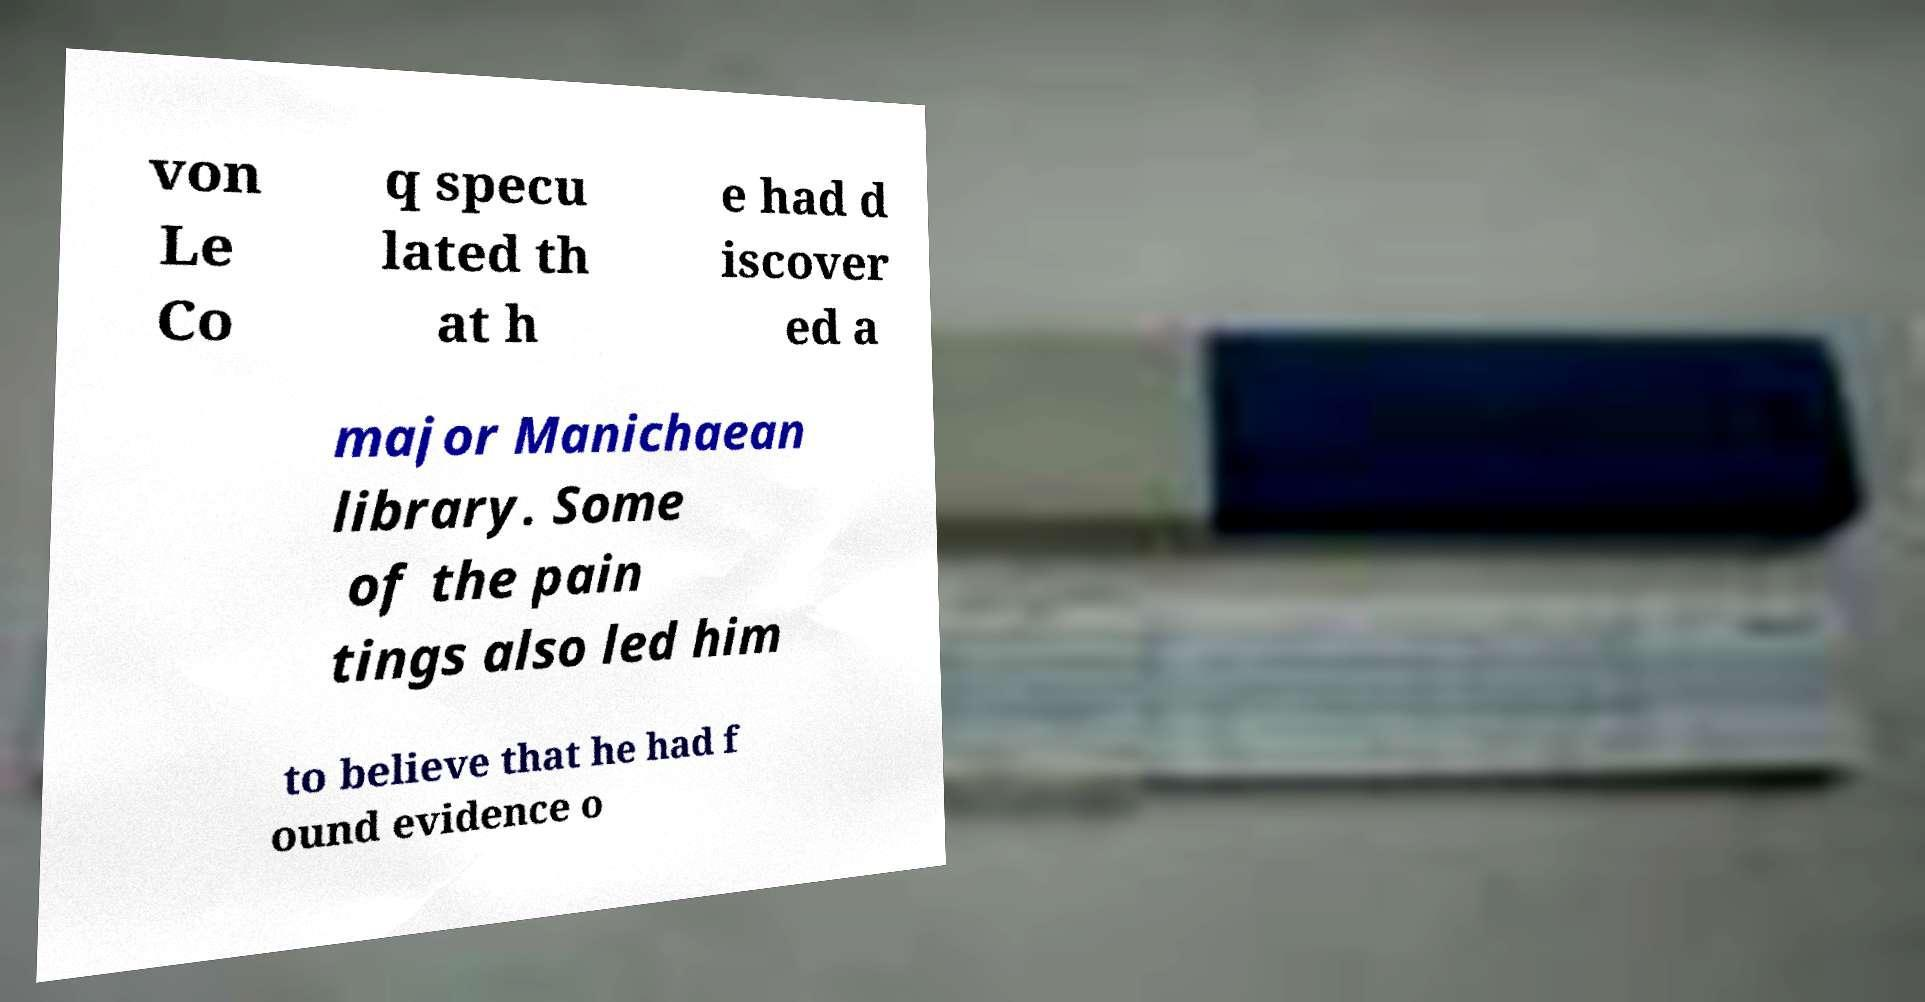Please read and relay the text visible in this image. What does it say? von Le Co q specu lated th at h e had d iscover ed a major Manichaean library. Some of the pain tings also led him to believe that he had f ound evidence o 